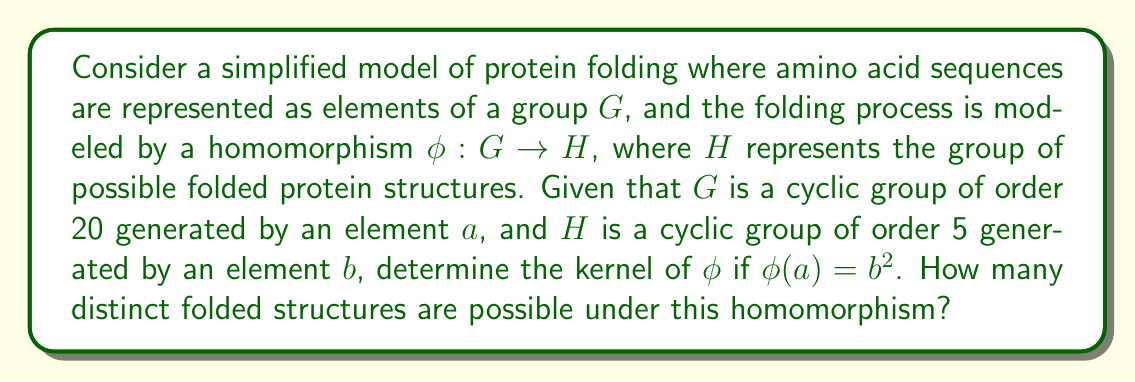Provide a solution to this math problem. To solve this problem, let's follow these steps:

1) First, we need to understand what $\phi(a) = b^2$ means in terms of the order of elements:
   
   $\text{ord}(a) = 20$ in $G$
   $\text{ord}(b) = 5$ in $H$
   $\phi(a) = b^2$ implies $\text{ord}(\phi(a)) = \text{ord}(b^2) = 5/\gcd(2,5) = 5$

2) By the Fundamental Homomorphism Theorem, we know that:
   
   $$G/\ker(\phi) \cong \text{Im}(\phi)$$

3) The order of the image of $\phi$ is the same as the order of $\phi(a)$, which is 5.

4) Using the Lagrange's theorem:
   
   $$|G| = |\ker(\phi)| \cdot |\text{Im}(\phi)|$$
   
   $20 = |\ker(\phi)| \cdot 5$

5) Solving this equation:
   
   $|\ker(\phi)| = 20/5 = 4$

6) The kernel of $\phi$ is a subgroup of $G$. Since $G$ is cyclic of order 20, its subgroups are cyclic groups of orders that divide 20. The only subgroup of order 4 is $\langle a^5 \rangle$.

7) Therefore, $\ker(\phi) = \{e, a^5, a^{10}, a^{15}\}$

8) The number of distinct folded structures is equal to the order of the image of $\phi$, which we found to be 5.
Answer: The kernel of $\phi$ is $\ker(\phi) = \{e, a^5, a^{10}, a^{15}\}$, and there are 5 distinct folded structures possible under this homomorphism. 